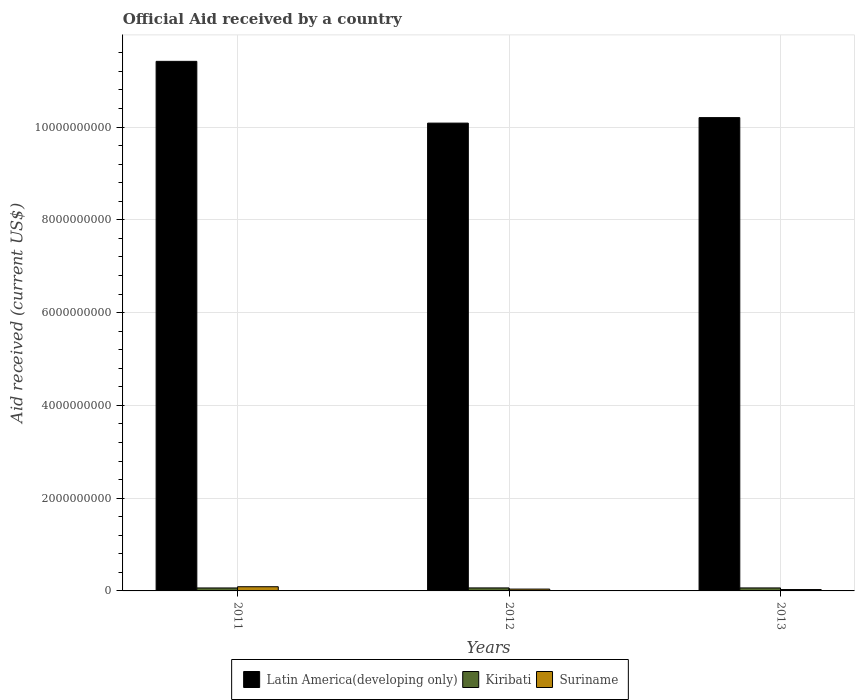How many different coloured bars are there?
Offer a very short reply. 3. Are the number of bars on each tick of the X-axis equal?
Provide a succinct answer. Yes. What is the label of the 3rd group of bars from the left?
Keep it short and to the point. 2013. What is the net official aid received in Suriname in 2012?
Provide a short and direct response. 3.96e+07. Across all years, what is the maximum net official aid received in Suriname?
Your answer should be very brief. 9.06e+07. Across all years, what is the minimum net official aid received in Kiribati?
Make the answer very short. 6.39e+07. In which year was the net official aid received in Suriname maximum?
Your answer should be very brief. 2011. In which year was the net official aid received in Kiribati minimum?
Keep it short and to the point. 2011. What is the total net official aid received in Latin America(developing only) in the graph?
Keep it short and to the point. 3.17e+1. What is the difference between the net official aid received in Kiribati in 2011 and that in 2013?
Your answer should be compact. -5.20e+05. What is the difference between the net official aid received in Suriname in 2011 and the net official aid received in Kiribati in 2013?
Offer a terse response. 2.61e+07. What is the average net official aid received in Suriname per year?
Provide a short and direct response. 5.33e+07. In the year 2013, what is the difference between the net official aid received in Suriname and net official aid received in Latin America(developing only)?
Ensure brevity in your answer.  -1.02e+1. What is the ratio of the net official aid received in Latin America(developing only) in 2012 to that in 2013?
Keep it short and to the point. 0.99. Is the net official aid received in Kiribati in 2012 less than that in 2013?
Make the answer very short. No. Is the difference between the net official aid received in Suriname in 2012 and 2013 greater than the difference between the net official aid received in Latin America(developing only) in 2012 and 2013?
Provide a succinct answer. Yes. What is the difference between the highest and the second highest net official aid received in Kiribati?
Offer a terse response. 2.10e+05. What is the difference between the highest and the lowest net official aid received in Suriname?
Offer a terse response. 6.07e+07. What does the 3rd bar from the left in 2012 represents?
Give a very brief answer. Suriname. What does the 3rd bar from the right in 2013 represents?
Your answer should be compact. Latin America(developing only). Are all the bars in the graph horizontal?
Offer a terse response. No. How are the legend labels stacked?
Keep it short and to the point. Horizontal. What is the title of the graph?
Your response must be concise. Official Aid received by a country. Does "Thailand" appear as one of the legend labels in the graph?
Give a very brief answer. No. What is the label or title of the X-axis?
Your answer should be very brief. Years. What is the label or title of the Y-axis?
Provide a succinct answer. Aid received (current US$). What is the Aid received (current US$) of Latin America(developing only) in 2011?
Your answer should be very brief. 1.14e+1. What is the Aid received (current US$) in Kiribati in 2011?
Ensure brevity in your answer.  6.39e+07. What is the Aid received (current US$) in Suriname in 2011?
Your answer should be very brief. 9.06e+07. What is the Aid received (current US$) in Latin America(developing only) in 2012?
Keep it short and to the point. 1.01e+1. What is the Aid received (current US$) of Kiribati in 2012?
Give a very brief answer. 6.47e+07. What is the Aid received (current US$) in Suriname in 2012?
Your answer should be very brief. 3.96e+07. What is the Aid received (current US$) in Latin America(developing only) in 2013?
Provide a succinct answer. 1.02e+1. What is the Aid received (current US$) in Kiribati in 2013?
Your answer should be compact. 6.44e+07. What is the Aid received (current US$) of Suriname in 2013?
Make the answer very short. 2.99e+07. Across all years, what is the maximum Aid received (current US$) in Latin America(developing only)?
Provide a short and direct response. 1.14e+1. Across all years, what is the maximum Aid received (current US$) of Kiribati?
Offer a terse response. 6.47e+07. Across all years, what is the maximum Aid received (current US$) of Suriname?
Ensure brevity in your answer.  9.06e+07. Across all years, what is the minimum Aid received (current US$) of Latin America(developing only)?
Your answer should be very brief. 1.01e+1. Across all years, what is the minimum Aid received (current US$) in Kiribati?
Your answer should be compact. 6.39e+07. Across all years, what is the minimum Aid received (current US$) of Suriname?
Offer a very short reply. 2.99e+07. What is the total Aid received (current US$) of Latin America(developing only) in the graph?
Provide a succinct answer. 3.17e+1. What is the total Aid received (current US$) in Kiribati in the graph?
Make the answer very short. 1.93e+08. What is the total Aid received (current US$) of Suriname in the graph?
Your answer should be very brief. 1.60e+08. What is the difference between the Aid received (current US$) of Latin America(developing only) in 2011 and that in 2012?
Give a very brief answer. 1.33e+09. What is the difference between the Aid received (current US$) in Kiribati in 2011 and that in 2012?
Give a very brief answer. -7.30e+05. What is the difference between the Aid received (current US$) in Suriname in 2011 and that in 2012?
Provide a short and direct response. 5.10e+07. What is the difference between the Aid received (current US$) in Latin America(developing only) in 2011 and that in 2013?
Keep it short and to the point. 1.21e+09. What is the difference between the Aid received (current US$) of Kiribati in 2011 and that in 2013?
Give a very brief answer. -5.20e+05. What is the difference between the Aid received (current US$) in Suriname in 2011 and that in 2013?
Offer a very short reply. 6.07e+07. What is the difference between the Aid received (current US$) of Latin America(developing only) in 2012 and that in 2013?
Ensure brevity in your answer.  -1.19e+08. What is the difference between the Aid received (current US$) of Suriname in 2012 and that in 2013?
Ensure brevity in your answer.  9.71e+06. What is the difference between the Aid received (current US$) in Latin America(developing only) in 2011 and the Aid received (current US$) in Kiribati in 2012?
Your response must be concise. 1.14e+1. What is the difference between the Aid received (current US$) in Latin America(developing only) in 2011 and the Aid received (current US$) in Suriname in 2012?
Your response must be concise. 1.14e+1. What is the difference between the Aid received (current US$) in Kiribati in 2011 and the Aid received (current US$) in Suriname in 2012?
Keep it short and to the point. 2.43e+07. What is the difference between the Aid received (current US$) of Latin America(developing only) in 2011 and the Aid received (current US$) of Kiribati in 2013?
Provide a succinct answer. 1.14e+1. What is the difference between the Aid received (current US$) in Latin America(developing only) in 2011 and the Aid received (current US$) in Suriname in 2013?
Offer a terse response. 1.14e+1. What is the difference between the Aid received (current US$) in Kiribati in 2011 and the Aid received (current US$) in Suriname in 2013?
Offer a terse response. 3.40e+07. What is the difference between the Aid received (current US$) in Latin America(developing only) in 2012 and the Aid received (current US$) in Kiribati in 2013?
Make the answer very short. 1.00e+1. What is the difference between the Aid received (current US$) of Latin America(developing only) in 2012 and the Aid received (current US$) of Suriname in 2013?
Make the answer very short. 1.01e+1. What is the difference between the Aid received (current US$) of Kiribati in 2012 and the Aid received (current US$) of Suriname in 2013?
Keep it short and to the point. 3.48e+07. What is the average Aid received (current US$) in Latin America(developing only) per year?
Provide a succinct answer. 1.06e+1. What is the average Aid received (current US$) of Kiribati per year?
Provide a succinct answer. 6.43e+07. What is the average Aid received (current US$) of Suriname per year?
Offer a terse response. 5.33e+07. In the year 2011, what is the difference between the Aid received (current US$) in Latin America(developing only) and Aid received (current US$) in Kiribati?
Offer a very short reply. 1.14e+1. In the year 2011, what is the difference between the Aid received (current US$) in Latin America(developing only) and Aid received (current US$) in Suriname?
Provide a short and direct response. 1.13e+1. In the year 2011, what is the difference between the Aid received (current US$) of Kiribati and Aid received (current US$) of Suriname?
Make the answer very short. -2.66e+07. In the year 2012, what is the difference between the Aid received (current US$) of Latin America(developing only) and Aid received (current US$) of Kiribati?
Offer a very short reply. 1.00e+1. In the year 2012, what is the difference between the Aid received (current US$) in Latin America(developing only) and Aid received (current US$) in Suriname?
Provide a short and direct response. 1.00e+1. In the year 2012, what is the difference between the Aid received (current US$) in Kiribati and Aid received (current US$) in Suriname?
Provide a succinct answer. 2.51e+07. In the year 2013, what is the difference between the Aid received (current US$) in Latin America(developing only) and Aid received (current US$) in Kiribati?
Provide a succinct answer. 1.01e+1. In the year 2013, what is the difference between the Aid received (current US$) of Latin America(developing only) and Aid received (current US$) of Suriname?
Keep it short and to the point. 1.02e+1. In the year 2013, what is the difference between the Aid received (current US$) of Kiribati and Aid received (current US$) of Suriname?
Ensure brevity in your answer.  3.46e+07. What is the ratio of the Aid received (current US$) of Latin America(developing only) in 2011 to that in 2012?
Provide a succinct answer. 1.13. What is the ratio of the Aid received (current US$) in Kiribati in 2011 to that in 2012?
Provide a short and direct response. 0.99. What is the ratio of the Aid received (current US$) in Suriname in 2011 to that in 2012?
Keep it short and to the point. 2.29. What is the ratio of the Aid received (current US$) of Latin America(developing only) in 2011 to that in 2013?
Ensure brevity in your answer.  1.12. What is the ratio of the Aid received (current US$) of Suriname in 2011 to that in 2013?
Your answer should be compact. 3.03. What is the ratio of the Aid received (current US$) in Latin America(developing only) in 2012 to that in 2013?
Keep it short and to the point. 0.99. What is the ratio of the Aid received (current US$) of Kiribati in 2012 to that in 2013?
Your answer should be very brief. 1. What is the ratio of the Aid received (current US$) of Suriname in 2012 to that in 2013?
Keep it short and to the point. 1.32. What is the difference between the highest and the second highest Aid received (current US$) in Latin America(developing only)?
Make the answer very short. 1.21e+09. What is the difference between the highest and the second highest Aid received (current US$) in Kiribati?
Give a very brief answer. 2.10e+05. What is the difference between the highest and the second highest Aid received (current US$) of Suriname?
Ensure brevity in your answer.  5.10e+07. What is the difference between the highest and the lowest Aid received (current US$) of Latin America(developing only)?
Your answer should be compact. 1.33e+09. What is the difference between the highest and the lowest Aid received (current US$) of Kiribati?
Provide a succinct answer. 7.30e+05. What is the difference between the highest and the lowest Aid received (current US$) of Suriname?
Give a very brief answer. 6.07e+07. 